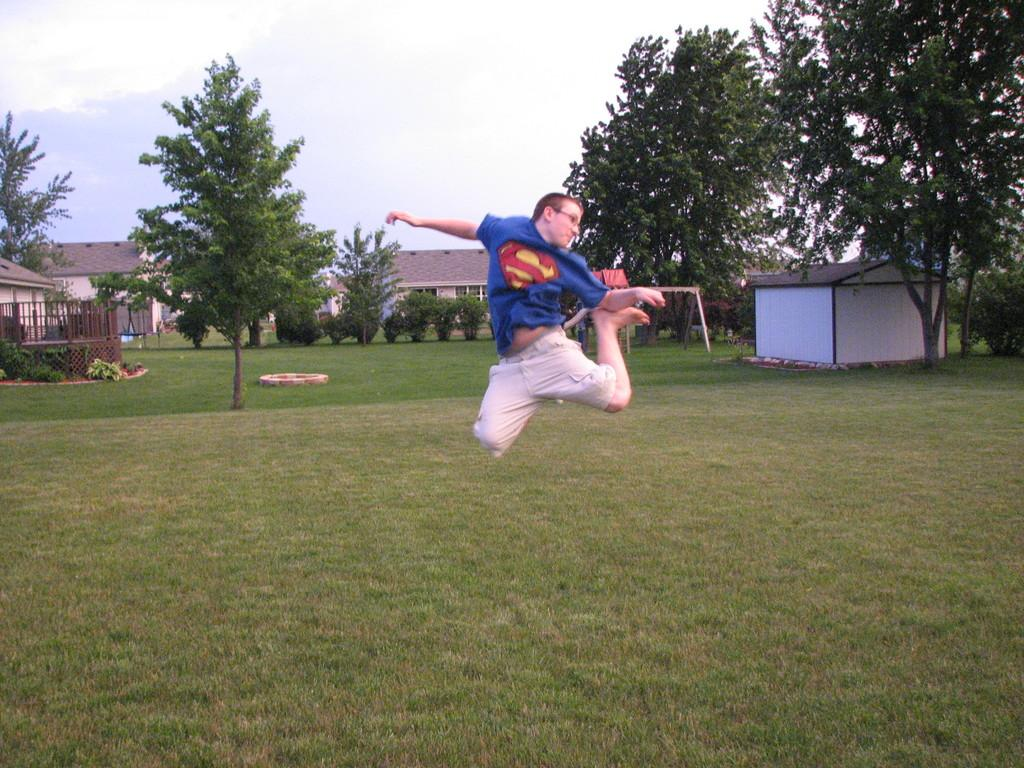What type of vegetation is present in the image? There is grass in the image. Can you describe the person in the image? There is a person in the image. What can be seen in the background of the image? There are trees and houses in the background of the image. What is visible in the sky in the background of the image? There are clouds in the sky in the background of the image. What type of brick is used to construct the church in the image? There is no church present in the image, so it is not possible to determine the type of brick used in its construction. 